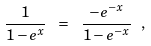Convert formula to latex. <formula><loc_0><loc_0><loc_500><loc_500>\frac { 1 } { 1 - e ^ { x } } \ = \ \frac { - e ^ { - x } } { 1 - e ^ { - x } } \ ,</formula> 